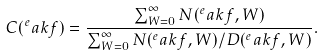Convert formula to latex. <formula><loc_0><loc_0><loc_500><loc_500>C ( ^ { e } a k f ) = \frac { \sum _ { W = 0 } ^ { \infty } N ( ^ { e } a k f , W ) } { \sum _ { W = 0 } ^ { \infty } N ( ^ { e } a k f , W ) / D ( ^ { e } a k f , W ) } .</formula> 